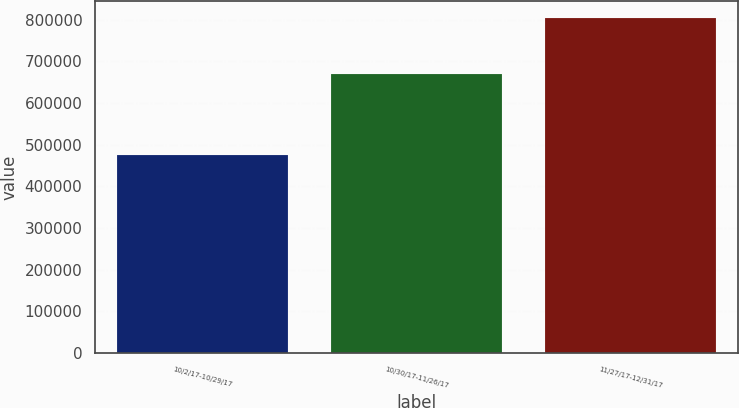Convert chart to OTSL. <chart><loc_0><loc_0><loc_500><loc_500><bar_chart><fcel>10/2/17-10/29/17<fcel>10/30/17-11/26/17<fcel>11/27/17-12/31/17<nl><fcel>475000<fcel>669835<fcel>803451<nl></chart> 